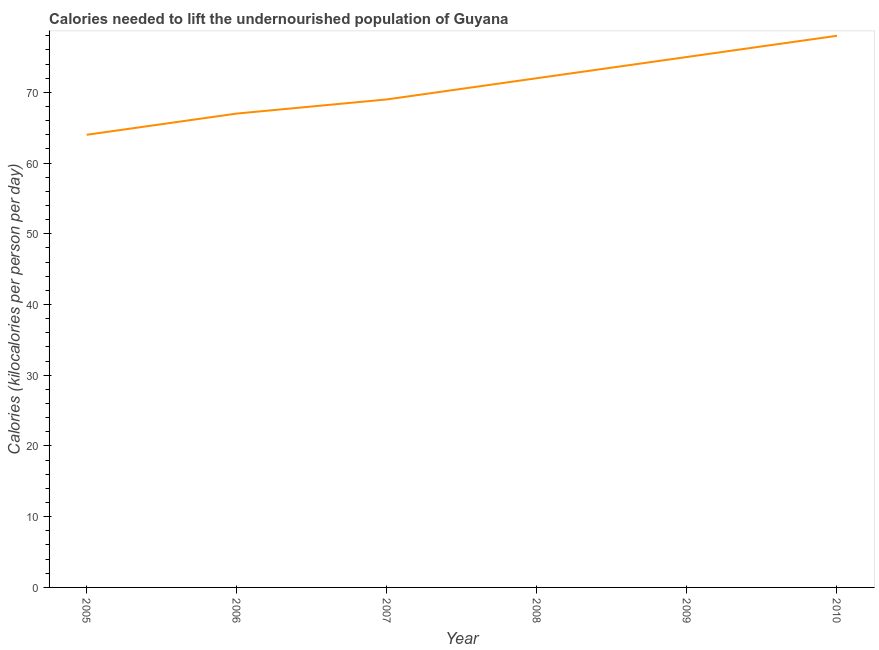What is the depth of food deficit in 2007?
Your answer should be very brief. 69. Across all years, what is the maximum depth of food deficit?
Provide a succinct answer. 78. Across all years, what is the minimum depth of food deficit?
Your answer should be very brief. 64. What is the sum of the depth of food deficit?
Offer a terse response. 425. What is the difference between the depth of food deficit in 2005 and 2008?
Give a very brief answer. -8. What is the average depth of food deficit per year?
Keep it short and to the point. 70.83. What is the median depth of food deficit?
Keep it short and to the point. 70.5. In how many years, is the depth of food deficit greater than 24 kilocalories?
Offer a terse response. 6. Is the depth of food deficit in 2006 less than that in 2010?
Your answer should be compact. Yes. Is the sum of the depth of food deficit in 2005 and 2010 greater than the maximum depth of food deficit across all years?
Keep it short and to the point. Yes. What is the difference between the highest and the lowest depth of food deficit?
Your response must be concise. 14. Does the depth of food deficit monotonically increase over the years?
Offer a terse response. Yes. What is the difference between two consecutive major ticks on the Y-axis?
Your answer should be compact. 10. Are the values on the major ticks of Y-axis written in scientific E-notation?
Offer a very short reply. No. What is the title of the graph?
Offer a very short reply. Calories needed to lift the undernourished population of Guyana. What is the label or title of the Y-axis?
Offer a very short reply. Calories (kilocalories per person per day). What is the Calories (kilocalories per person per day) in 2010?
Make the answer very short. 78. What is the difference between the Calories (kilocalories per person per day) in 2005 and 2006?
Give a very brief answer. -3. What is the difference between the Calories (kilocalories per person per day) in 2005 and 2007?
Your answer should be very brief. -5. What is the difference between the Calories (kilocalories per person per day) in 2006 and 2007?
Offer a very short reply. -2. What is the difference between the Calories (kilocalories per person per day) in 2006 and 2009?
Ensure brevity in your answer.  -8. What is the difference between the Calories (kilocalories per person per day) in 2006 and 2010?
Offer a terse response. -11. What is the difference between the Calories (kilocalories per person per day) in 2007 and 2010?
Make the answer very short. -9. What is the ratio of the Calories (kilocalories per person per day) in 2005 to that in 2006?
Give a very brief answer. 0.95. What is the ratio of the Calories (kilocalories per person per day) in 2005 to that in 2007?
Offer a very short reply. 0.93. What is the ratio of the Calories (kilocalories per person per day) in 2005 to that in 2008?
Your answer should be very brief. 0.89. What is the ratio of the Calories (kilocalories per person per day) in 2005 to that in 2009?
Offer a very short reply. 0.85. What is the ratio of the Calories (kilocalories per person per day) in 2005 to that in 2010?
Your answer should be compact. 0.82. What is the ratio of the Calories (kilocalories per person per day) in 2006 to that in 2007?
Make the answer very short. 0.97. What is the ratio of the Calories (kilocalories per person per day) in 2006 to that in 2009?
Ensure brevity in your answer.  0.89. What is the ratio of the Calories (kilocalories per person per day) in 2006 to that in 2010?
Offer a terse response. 0.86. What is the ratio of the Calories (kilocalories per person per day) in 2007 to that in 2008?
Offer a terse response. 0.96. What is the ratio of the Calories (kilocalories per person per day) in 2007 to that in 2010?
Your answer should be compact. 0.89. What is the ratio of the Calories (kilocalories per person per day) in 2008 to that in 2010?
Provide a succinct answer. 0.92. 